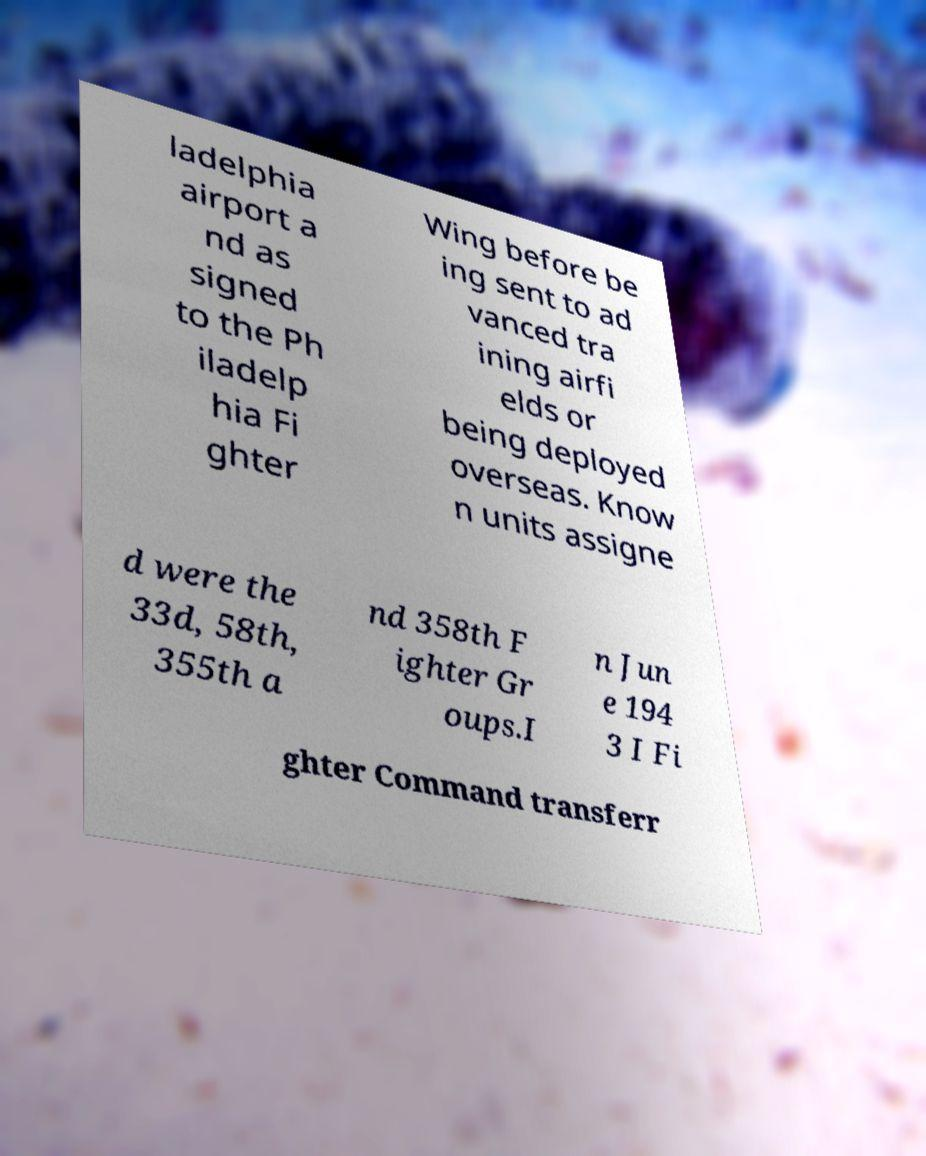Please read and relay the text visible in this image. What does it say? ladelphia airport a nd as signed to the Ph iladelp hia Fi ghter Wing before be ing sent to ad vanced tra ining airfi elds or being deployed overseas. Know n units assigne d were the 33d, 58th, 355th a nd 358th F ighter Gr oups.I n Jun e 194 3 I Fi ghter Command transferr 